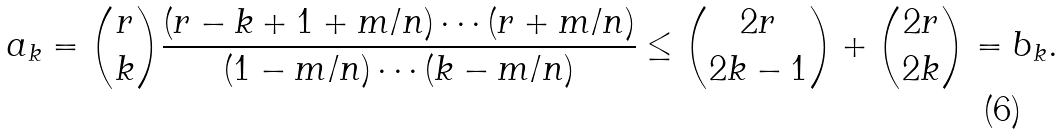<formula> <loc_0><loc_0><loc_500><loc_500>a _ { k } = { r \choose k } \frac { ( r - k + 1 + m / n ) \cdots ( r + m / n ) } { ( 1 - m / n ) \cdots ( k - m / n ) } \leq { 2 r \choose 2 k - 1 } + { 2 r \choose 2 k } = b _ { k } .</formula> 